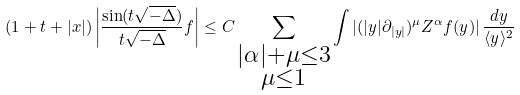<formula> <loc_0><loc_0><loc_500><loc_500>( 1 + t + | x | ) \left | \frac { \sin ( t \sqrt { - \Delta } ) } { t \sqrt { - \Delta } } f \right | \leq C \sum _ { \substack { | \alpha | + \mu \leq 3 \\ \mu \leq 1 } } \int | ( | y | \partial _ { | y | } ) ^ { \mu } Z ^ { \alpha } f ( y ) | \, \frac { d y } { \langle y \rangle ^ { 2 } }</formula> 